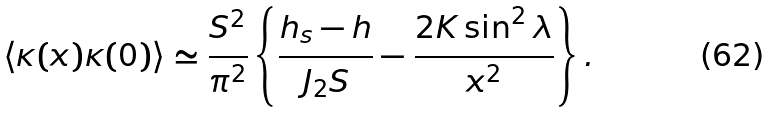Convert formula to latex. <formula><loc_0><loc_0><loc_500><loc_500>\langle \kappa ( x ) \kappa ( 0 ) \rangle \simeq \frac { S ^ { 2 } } { \pi ^ { 2 } } \left \{ \frac { h _ { s } - h } { J _ { 2 } S } - \frac { 2 K \sin ^ { 2 } \lambda } { x ^ { 2 } } \right \} .</formula> 